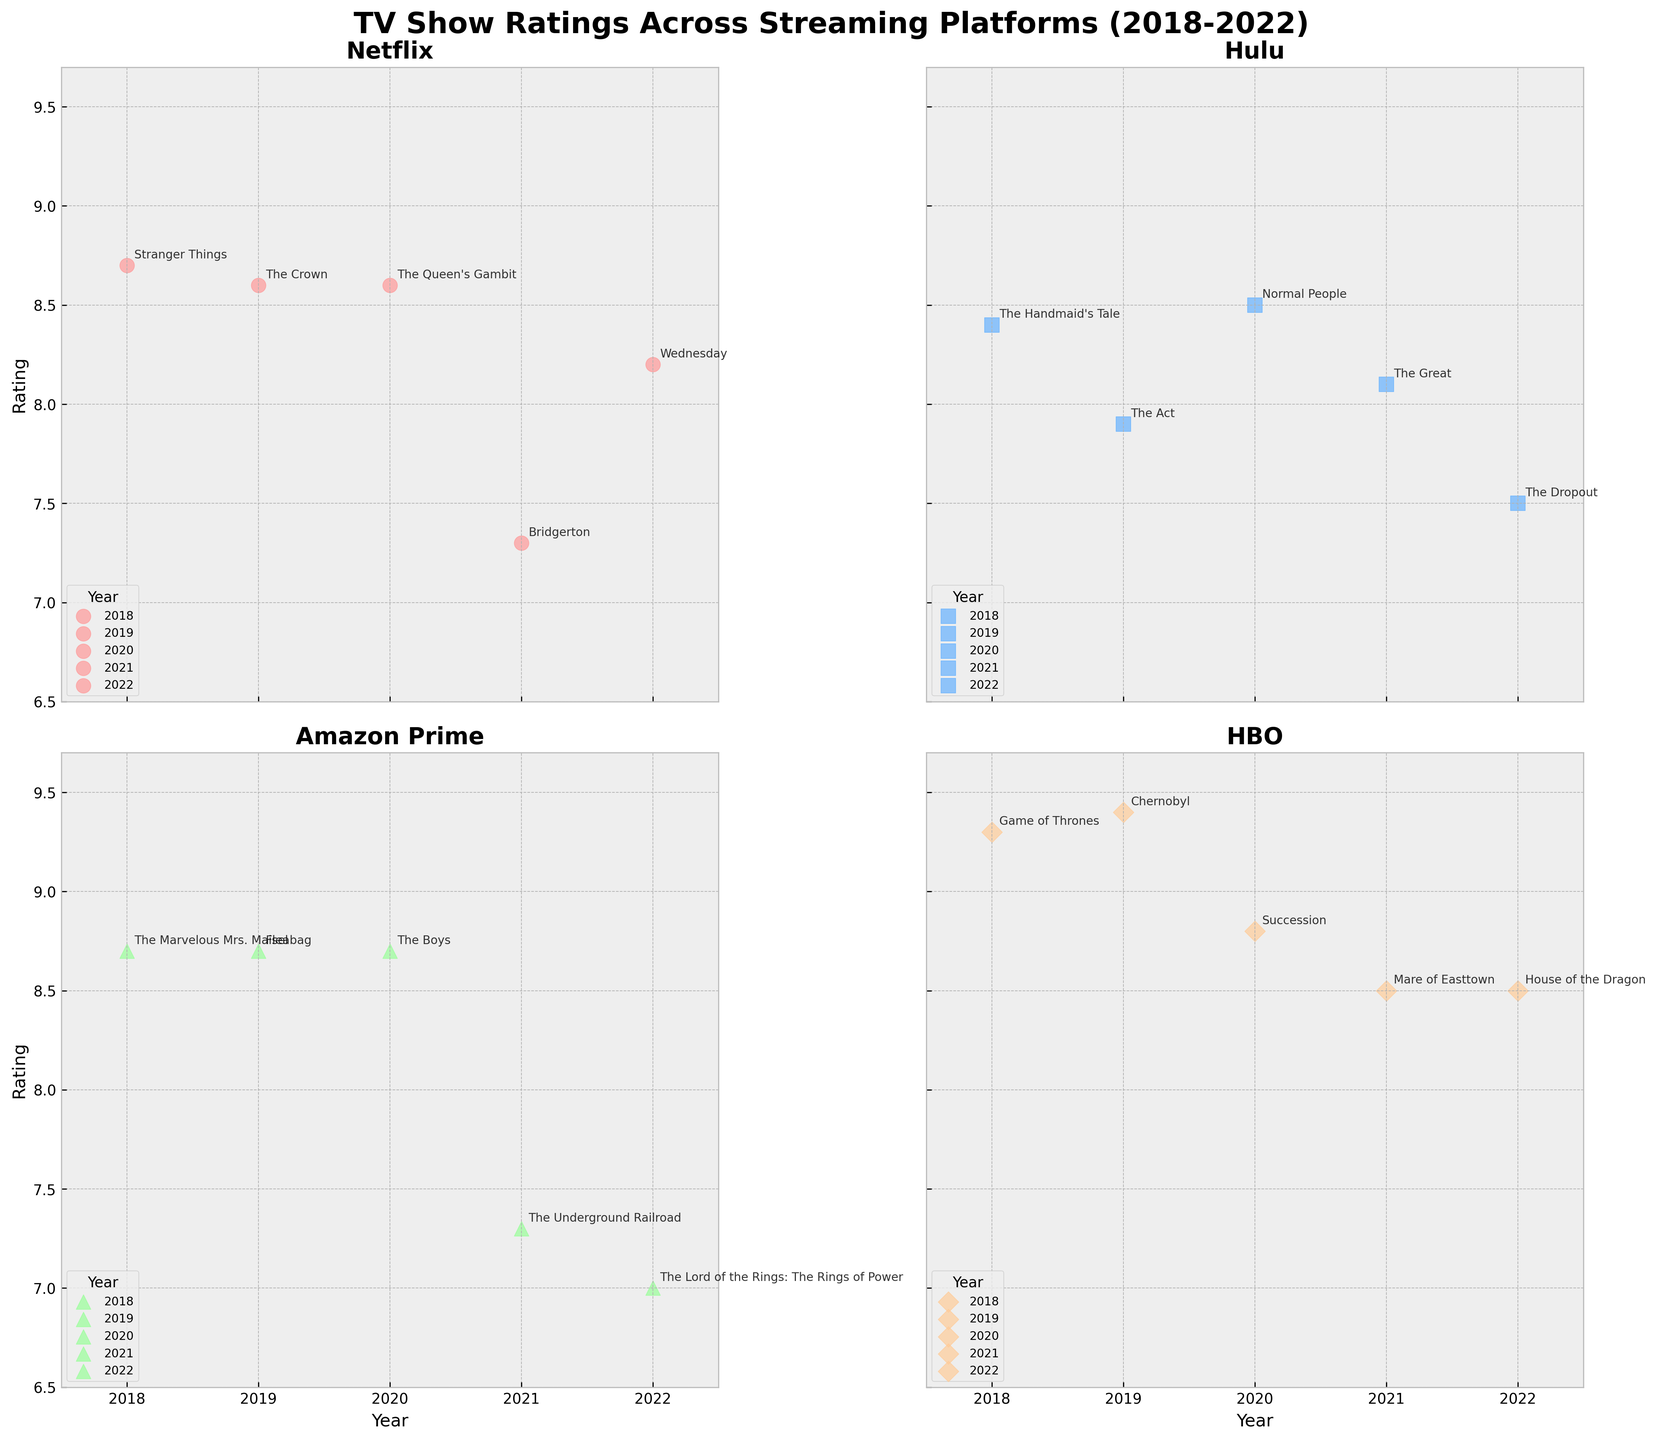What is the title of the figure? The title is typically displayed at the top of the figure. Here, it is "TV Show Ratings Across Streaming Platforms (2018-2022)" as seen at the top of the plot.
Answer: TV Show Ratings Across Streaming Platforms (2018-2022) What platform has the highest-rated show in 2019? To find the highest rating in 2019, locate the year 2019 on the x-axis and then check the ratings for all platforms. The highest rating in 2019 is 9.4 for HBO's "Chernobyl," as indicated by the scatter point and annotation of the show.
Answer: HBO Which year did Netflix have the most shows listed? Check which year has the most data points (scatter points) for Netflix. In this case, Netflix has one show listed in each year from 2018 to 2022, so no year exceeds another in the number of shows listed.
Answer: No single year; they are evenly distributed What color represents Hulu's data points? Each platform is represented by a different color. Hulu's scatter points can be seen in blue on the scatter plot.
Answer: Blue Which show has the lowest rating for Amazon Prime? To determine this, identify Amazon Prime's shows and their respective ratings. The lowest rating for Amazon Prime is 7.0 for "The Lord of the Rings: The Rings of Power," as indicated by the scatter point and annotation.
Answer: The Lord of the Rings: The Rings of Power Compare the ratings of HBO shows in 2018 and 2019. Which year had higher average ratings? Locate HBO's shows for 2018 and 2019. Ratings for 2018: "Game of Thrones" (9.3); for 2019: "Chernobyl" (9.4). Both years have one show, so compare the ratings directly. 2019 has a slightly higher rating of 9.4 compared to 9.3 in 2018.
Answer: 2019 What is the average rating of Netflix shows from 2020 to 2022? To calculate the average rating for Netflix from 2020 to 2022, find the ratings for this period: "The Queen’s Gambit" (8.6, 2020), "Bridgerton" (7.3, 2021), "Wednesday" (8.2, 2022). Average = (8.6 + 7.3 + 8.2) / 3 = 8.03.
Answer: 8.03 In which year did Hulu have the highest average rating? Check Hulu's show ratings for each year: 2018: 8.4; 2019: 7.9; 2020: 8.5; 2021: 8.1; 2022: 7.5. The highest average rating is in 2020 with a rating of 8.5.
Answer: 2020 Which platform consistently has shows with ratings above 8.0? Analyze each platform's shows and their ratings. HBO consistently has ratings above 8.0: 2018 (9.3), 2019 (9.4), 2020 (8.8), 2021 (8.5), 2022 (8.5).
Answer: HBO 